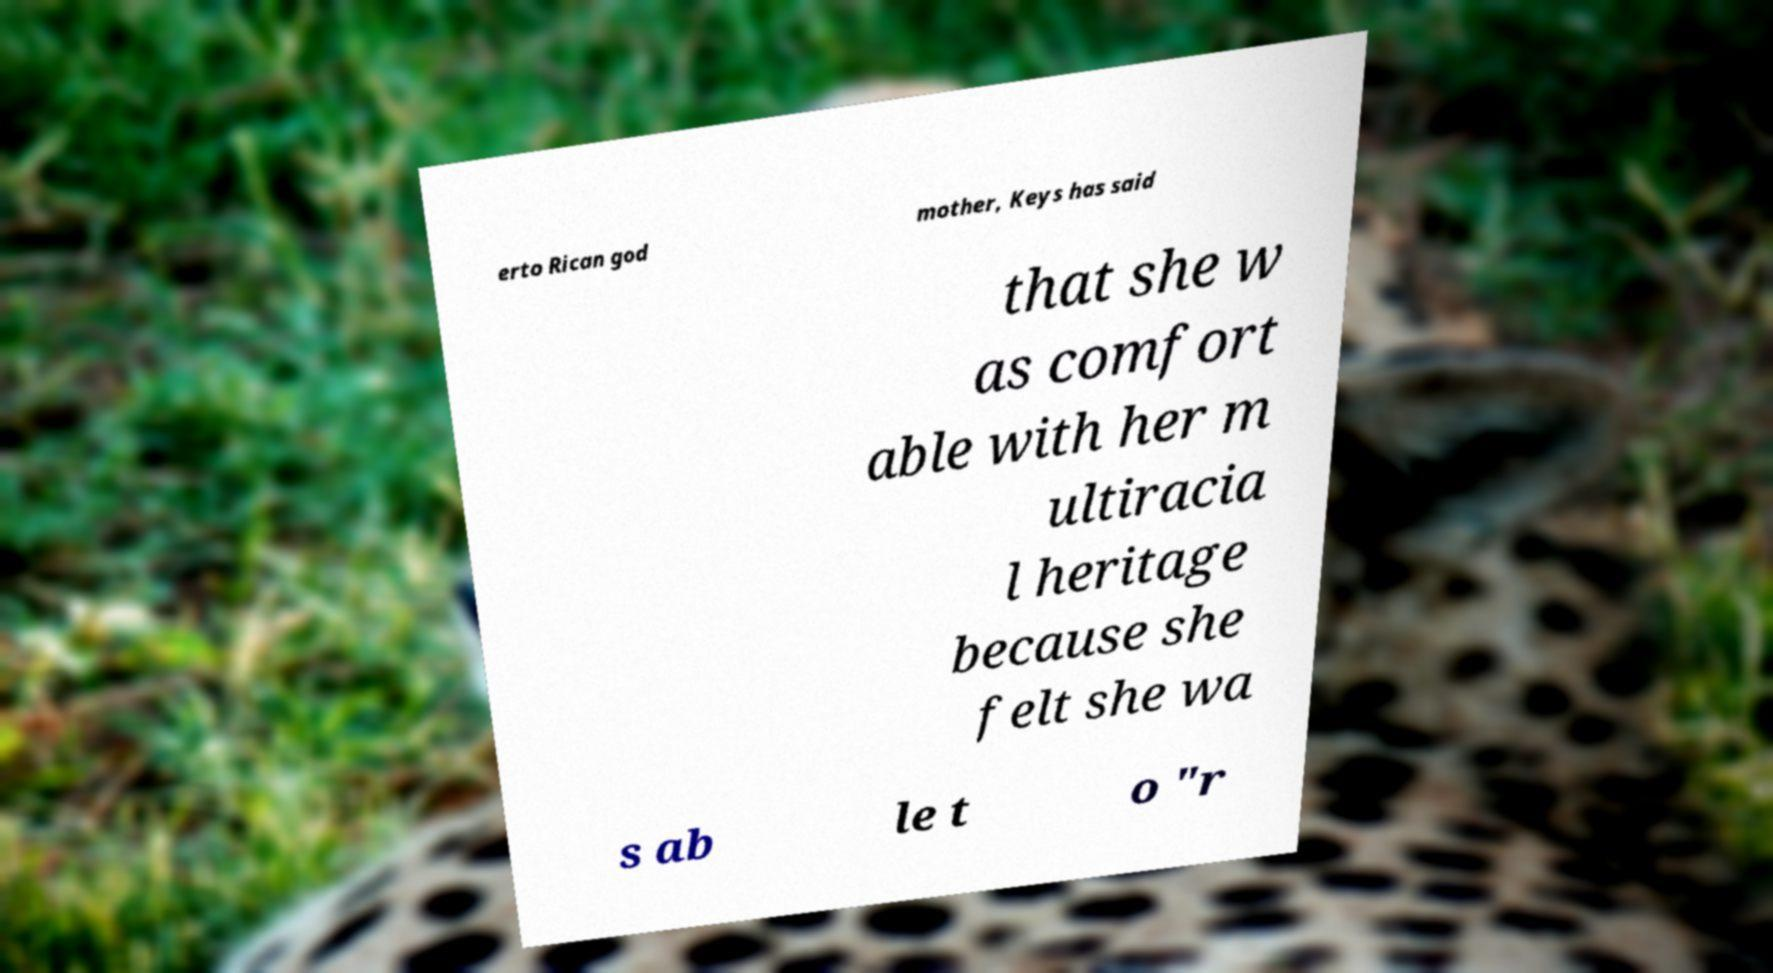Could you assist in decoding the text presented in this image and type it out clearly? erto Rican god mother, Keys has said that she w as comfort able with her m ultiracia l heritage because she felt she wa s ab le t o "r 